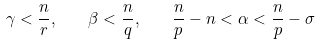<formula> <loc_0><loc_0><loc_500><loc_500>\gamma < \frac { n } { r } , \quad \beta < \frac { n } { q } , \quad \frac { n } { p } - n < \alpha < \frac { n } { p } - \sigma</formula> 